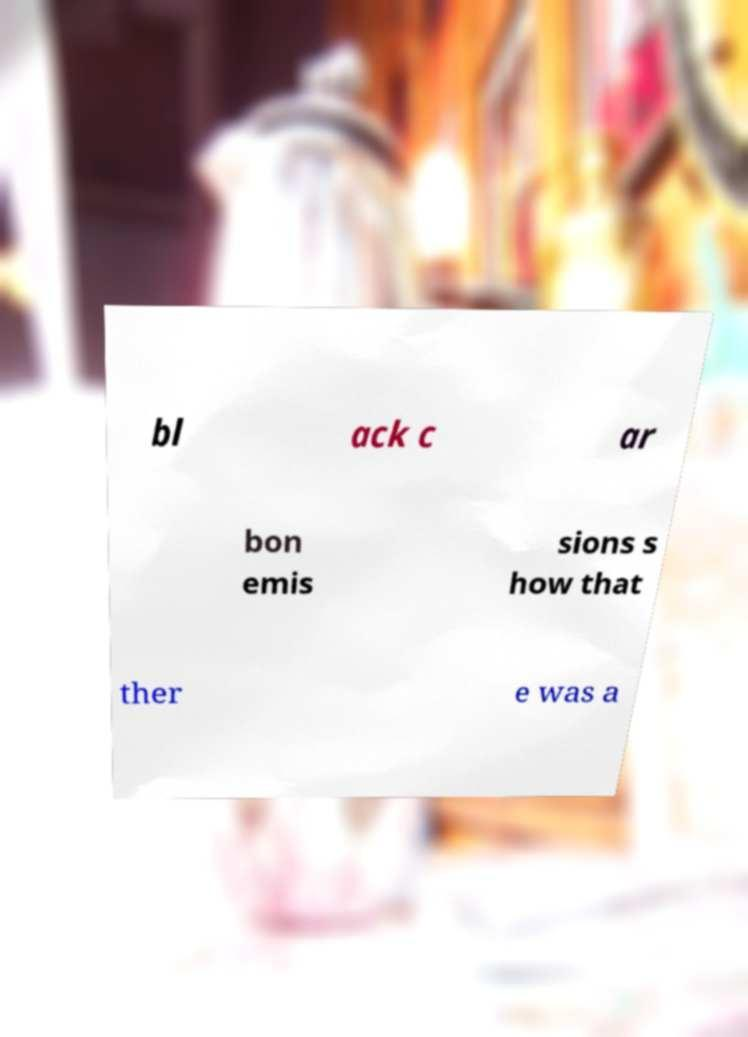Could you extract and type out the text from this image? bl ack c ar bon emis sions s how that ther e was a 